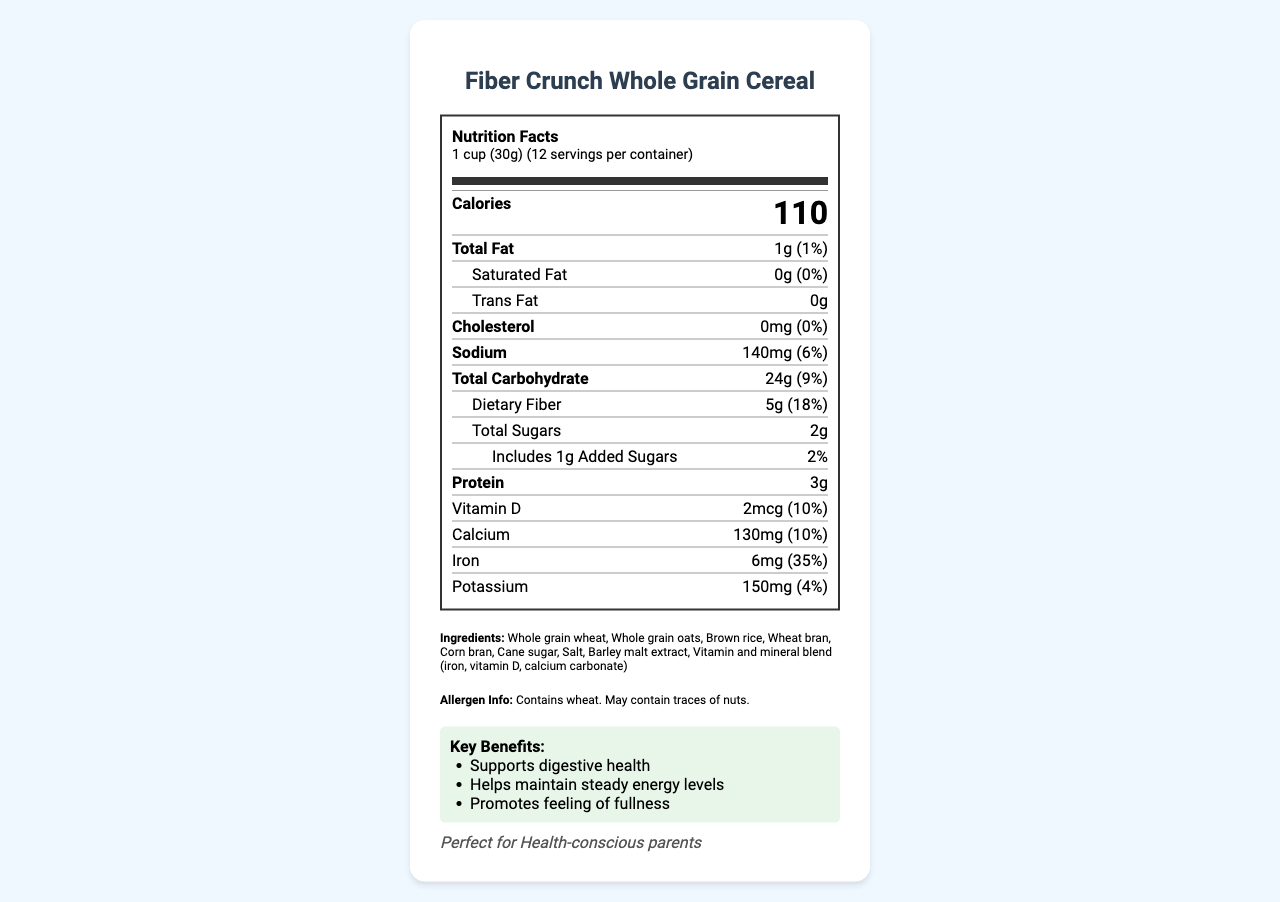What is the calorie count per serving? The label shows that each serving (1 cup or 30g) of Fiber Crunch Whole Grain Cereal contains 110 calories.
Answer: 110 How much dietary fiber is in one serving? The nutrition label indicates that there are 5g of dietary fiber per serving.
Answer: 5g What percentage of the daily value for iron does one serving provide? The document specifies that one serving provides 6mg of iron, which is 35% of the daily value.
Answer: 35% How many servings are in one container? The label states there are 12 servings per container.
Answer: 12 What are the first three ingredients listed? The ingredients section lists Whole grain wheat, Whole grain oats, and Brown rice as the first three ingredients.
Answer: Whole grain wheat, Whole grain oats, Brown rice Which of the following is a marketing claim for this cereal? A. Contains artificial colors B. High in fiber C. Low in calcium The marketing claims section lists "High in fiber."
Answer: B What is the serving size of this cereal? A. 1/2 cup (15g) B. 1 cup (30g) C. 2 cups (60g) The label specifies that the serving size is 1 cup (30g).
Answer: B Does this product contain artificial colors or flavors? The marketing claims assure that the cereal contains "No artificial colors or flavors."
Answer: No Is this cereal suitable for someone with a gluten allergy? The allergen information specifies that the product contains wheat, which implies it contains gluten.
Answer: No Summarize the main idea of this document. This document provides comprehensive information about Fiber Crunch Whole Grain Cereal, including its nutrition facts, key ingredients, marketing claims, target audience, key benefits, and allergen information. It highlights the product's appeal to health-conscious parents and details its distribution and marketing channels.
Answer: Fiber Crunch Whole Grain Cereal is a low-sugar, high-fiber breakfast option made from whole grains, aimed at health-conscious parents. The product highlights its benefits for digestive health, steady energy levels, and feeling of fullness, and is marketed through health blogs, parenting forums, fitness apps, and social media. It provides key nutrients like fiber, iron, and calcium while avoiding artificial colors and flavors, and is suitable for nutrition-focused millennials, fitness enthusiasts, and parents of young children. What is the average sugar content in competitors' cereals per serving? The competitor comparison section states that the average sugar content in similar products is 12g per serving.
Answer: 12g How much added sugar does this cereal have? The label indicates that there are 1g of added sugars in one serving.
Answer: 1g What is the total carbohydrate content per serving? The nutrition label shows that the total carbohydrate content per serving is 24g.
Answer: 24g What benefits does this cereal provide? The key benefits section lists three main benefits: supports digestive health, helps maintain steady energy levels, and promotes a feeling of fullness.
Answer: Supports digestive health, Helps maintain steady energy levels, Promotes feeling of fullness How much vitamin D is in one serving? The label indicates that each serving contains 2mcg of vitamin D.
Answer: 2mcg What percentage of the daily value for calcium does one serving provide? The nutrition label states that one serving provides 130mg of calcium, which is 10% of the daily value.
Answer: 10% What is the batch number for this product? The tracking information indicates the batch number is 2023-05-15-A.
Answer: 2023-05-15-A What is the total fat content per serving? The nutrition facts label shows a total fat content of 1g per serving.
Answer: 1g How does this cereal compare to competitors in terms of fiber content? The competitor comparison section states that the average fiber content in similar products is 2g per serving, while Fiber Crunch Whole Grain Cereal contains 5g of fiber per serving.
Answer: Higher What is the sodium content per serving? The label indicates that there are 140mg of sodium per serving.
Answer: 140mg How much protein is provided in each serving? The nutrition facts label shows that there are 3g of protein per serving.
Answer: 3g Where can this product be found? The tracking information mentions that the cereal is available in the health food aisles of major supermarkets.
Answer: Available in health food aisles of major supermarkets 